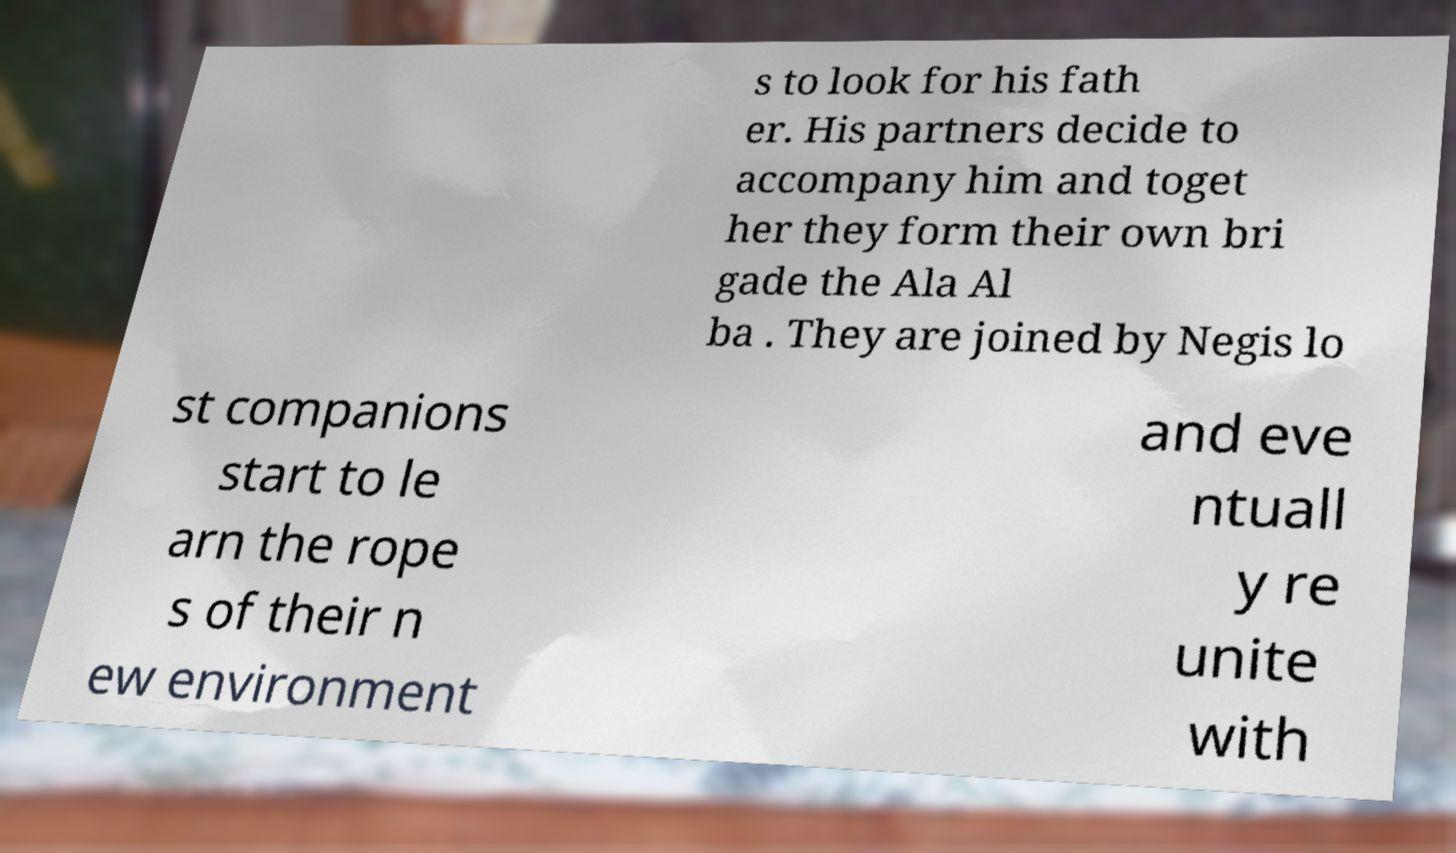I need the written content from this picture converted into text. Can you do that? s to look for his fath er. His partners decide to accompany him and toget her they form their own bri gade the Ala Al ba . They are joined by Negis lo st companions start to le arn the rope s of their n ew environment and eve ntuall y re unite with 